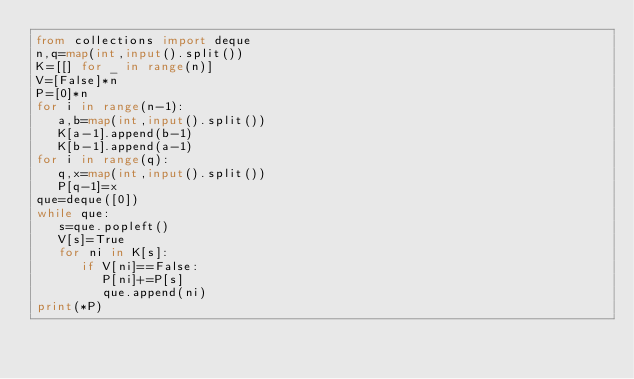Convert code to text. <code><loc_0><loc_0><loc_500><loc_500><_Python_>from collections import deque
n,q=map(int,input().split())
K=[[] for _ in range(n)]
V=[False]*n
P=[0]*n
for i in range(n-1):
   a,b=map(int,input().split())
   K[a-1].append(b-1)
   K[b-1].append(a-1)
for i in range(q):
   q,x=map(int,input().split())
   P[q-1]=x
que=deque([0])
while que:
   s=que.popleft()
   V[s]=True
   for ni in K[s]:
      if V[ni]==False:
         P[ni]+=P[s]
         que.append(ni)
print(*P)</code> 